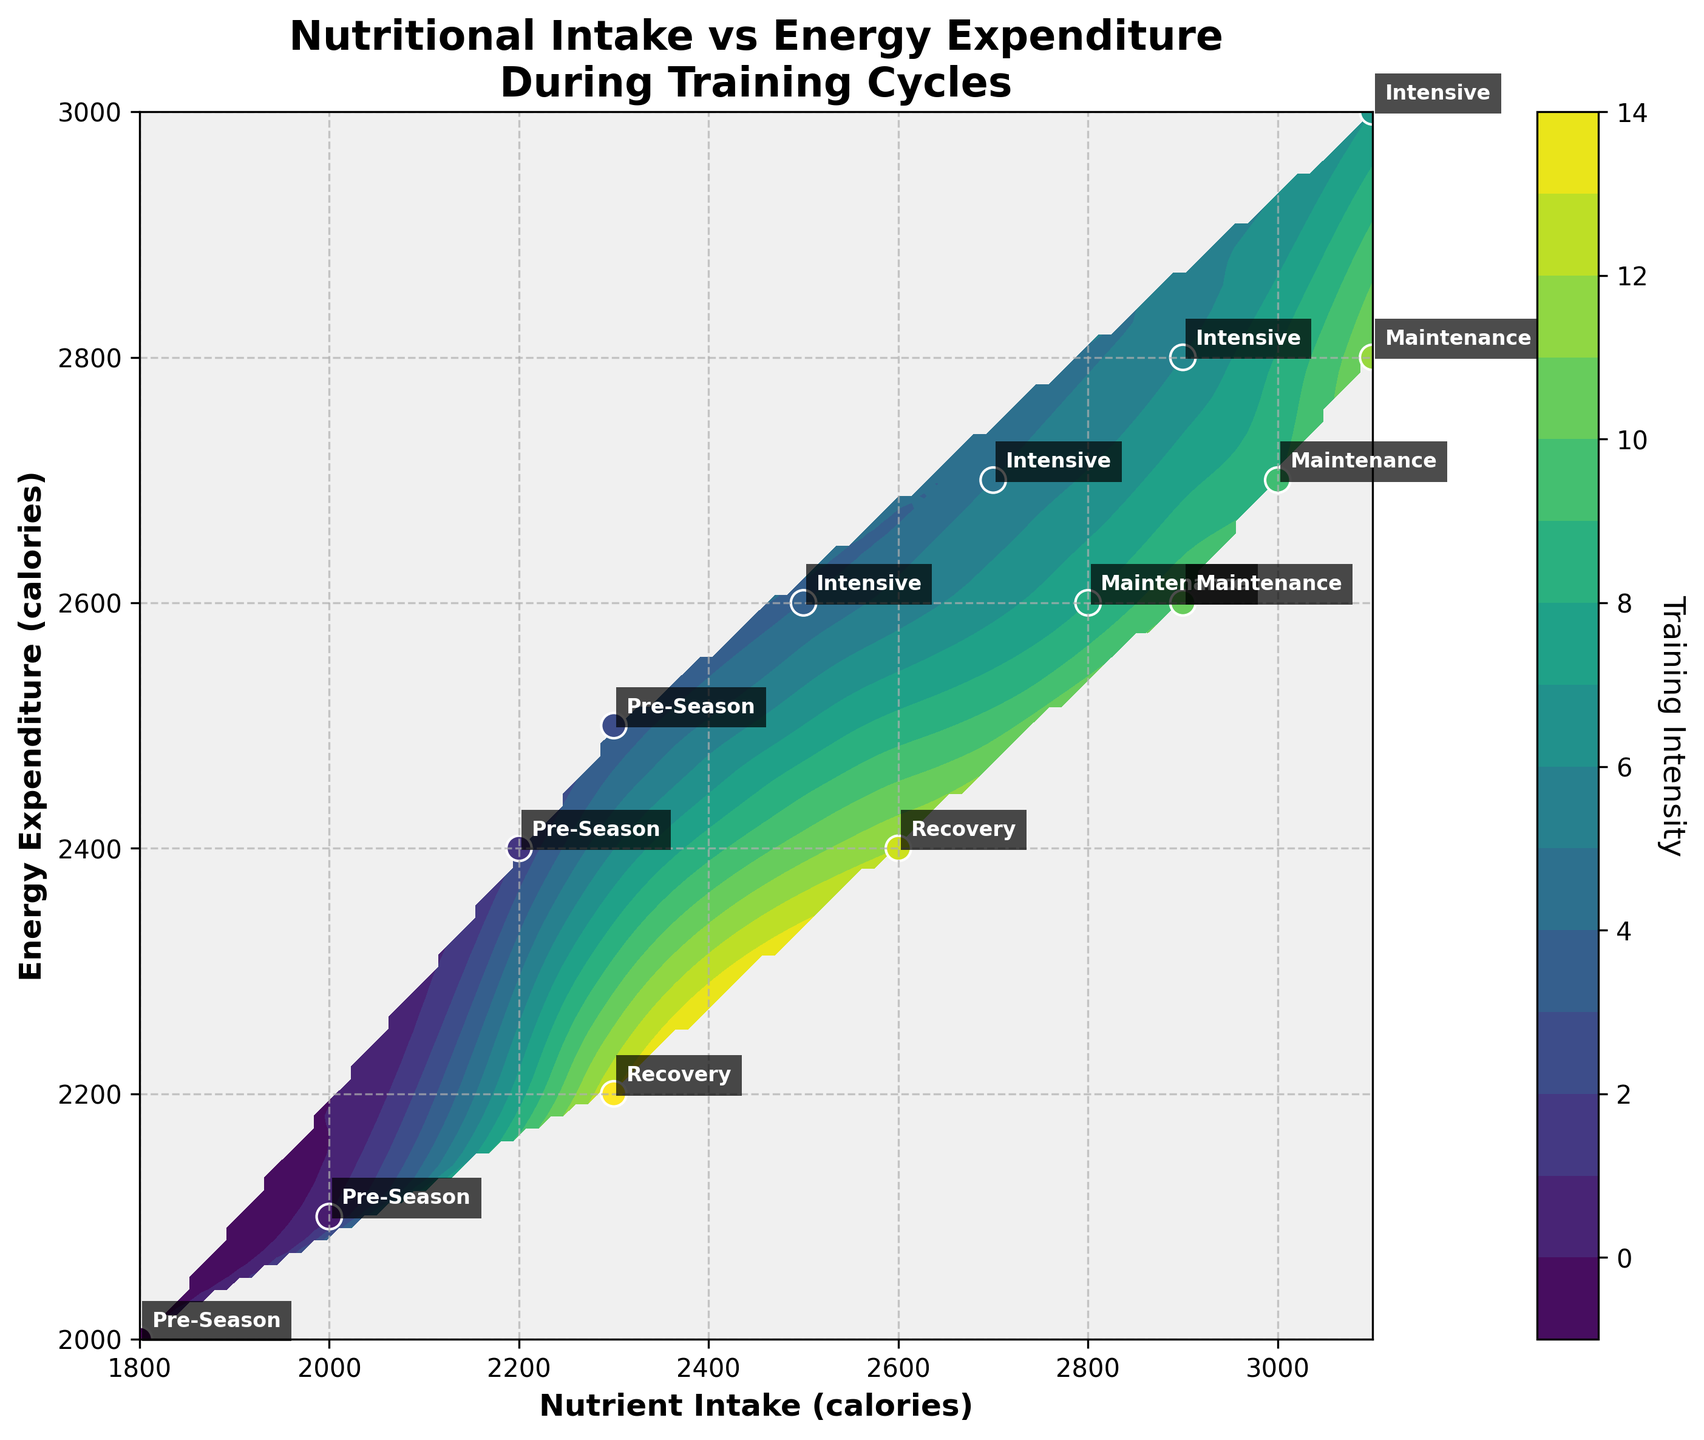What is the title of the plot? The title of the plot is usually found at the top of the figure, providing a brief description of what the figure represents.
Answer: Nutritional Intake vs Energy Expenditure During Training Cycles What are the axis labels in this plot? The axis labels describe what is being shown on each axis. Typically, the x-axis label is provided on the bottom and the y-axis label on the left side of the plot.
Answer: Nutrient Intake (calories), Energy Expenditure (calories) How many training phases are annotated in the plot? By looking at the labels close to each data point, we can count the number of distinct training phases mentioned.
Answer: Four (Pre-Season, Intensive, Maintenance, Recovery) Which training phase has the highest nutrient intake? To find this, look for the highest value on the x-axis and determine the training phase label associated with that data point.
Answer: Intensive What is the range of energy expenditure during the Pre-Season phase? Identify the data points labeled as "Pre-Season" and note their energy expenditure values, then compute the range.
Answer: 2000 to 2500 calories Compare the nutrient intake and energy expenditure between Intensive and Recovery phases. Which phase has higher average values? Extract and calculate the average of the nutrient intake and energy expenditure for both phases, then compare the averages.
- Intensive: Nutrient Intake (2500, 2700, 2900, 3100), Energy Expenditure (2600, 2700, 2800, 3000)
- Recovery: Nutrient Intake (2600, 2300), Energy Expenditure (2400, 2200)
- Average Nutrient Intake: Intensive = 2800, Recovery = 2450
- Average Energy Expenditure: Intensive = 2775, Recovery = 2300
Answer: Intensive What is the general trend of nutrient intake versus energy expenditure during the training cycles? By observing the overall distribution of data points and the contour lines, we can describe the relationship between nutrient intake and energy expenditure. Contour plots often reveal patterns or trends in data.
Answer: Both nutrient intake and energy expenditure tend to increase together Identify the lowest energy expenditure value in the plot and its associated training phase. Locate the data point with the lowest value on the y-axis and read off its associated training phase.
Answer: 2200 calories, Recovery Do the scatter points follow a linear relationship between nutrient intake and energy expenditure? By examining the positioning of the scatter points, determine if they roughly form a straight line, indicating a linear relationship.
Answer: Yes 